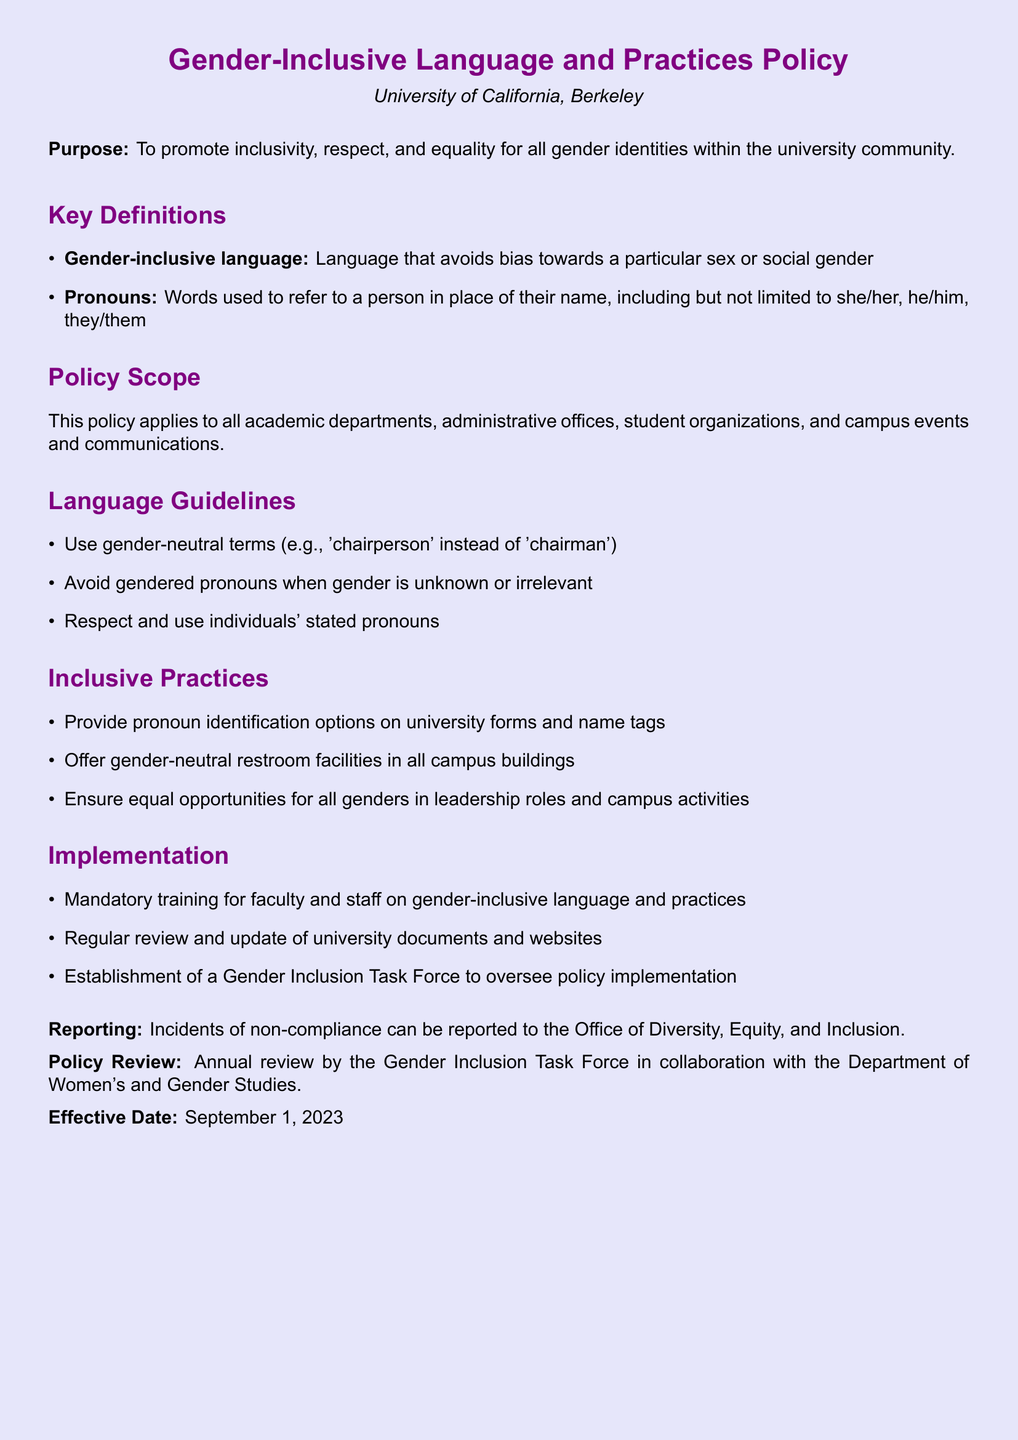What is the purpose of the policy? The purpose of the policy is stated clearly at the beginning, emphasizing the promotion of inclusivity, respect, and equality for all gender identities within the university community.
Answer: To promote inclusivity, respect, and equality for all gender identities within the university community What does "gender-inclusive language" refer to? The document defines "gender-inclusive language" as language that avoids bias towards a particular sex or social gender, making it clear what this term means.
Answer: Language that avoids bias towards a particular sex or social gender Which offices is the policy applicable to? The policy scope mentions that it applies to all academic departments, administrative offices, student organizations, and campus events and communications, indicating its broad reach.
Answer: All academic departments, administrative offices, student organizations, and campus events and communications What pronouns should individuals' preferences include according to the document? The document specifically lists examples of pronouns, which includes she/her, he/him, and they/them, indicating that these are examples of what should be respected and used.
Answer: She/her, he/him, they/them What is one of the inclusive practices mentioned in the document? The document lists several inclusive practices, and one example is the provision of pronoun identification options on university forms and name tags, showing a practical application of the policy.
Answer: Provide pronoun identification options on university forms and name tags When is the policy effective? The last section of the document clearly states the date when the policy comes into effect, which is important for understanding its implementation timeline.
Answer: September 1, 2023 What committee oversees the policy implementation? The policy implementation is overseen by a Gender Inclusion Task Force, as mentioned in the implementation section of the document.
Answer: Gender Inclusion Task Force How often will the policy be reviewed? The document specifies an annual review process, indicating that the policy will be regularly assessed for effectiveness and relevance.
Answer: Annual review 